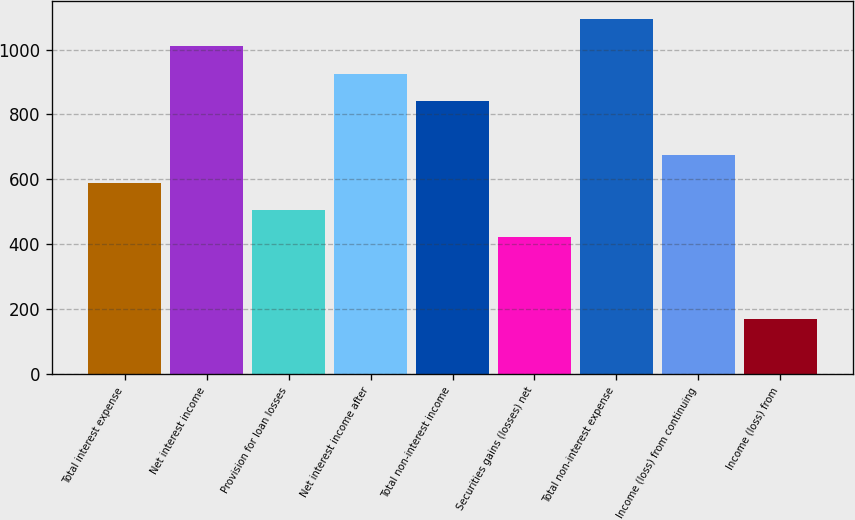Convert chart to OTSL. <chart><loc_0><loc_0><loc_500><loc_500><bar_chart><fcel>Total interest expense<fcel>Net interest income<fcel>Provision for loan losses<fcel>Net interest income after<fcel>Total non-interest income<fcel>Securities gains (losses) net<fcel>Total non-interest expense<fcel>Income (loss) from continuing<fcel>Income (loss) from<nl><fcel>589.41<fcel>1010.41<fcel>505.21<fcel>926.21<fcel>842.01<fcel>421.01<fcel>1094.61<fcel>673.61<fcel>168.41<nl></chart> 